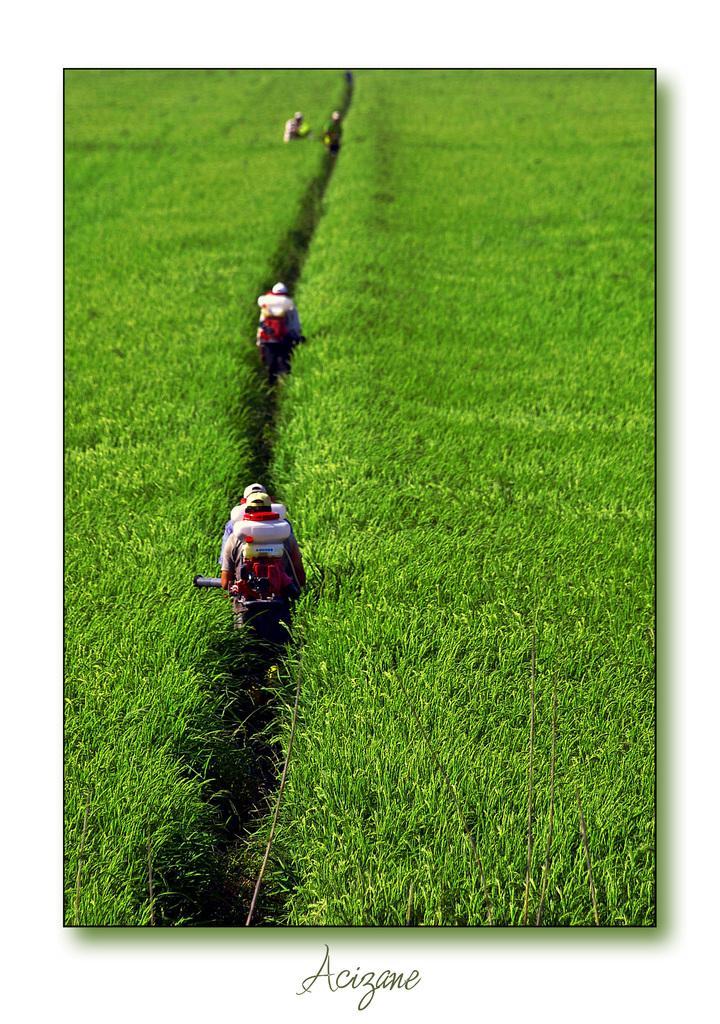Could you give a brief overview of what you see in this image? In this image there are persons standing in the center and there is grass on the ground and there is some text written on the image. 